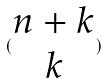Convert formula to latex. <formula><loc_0><loc_0><loc_500><loc_500>( \begin{matrix} n + k \\ k \end{matrix} )</formula> 